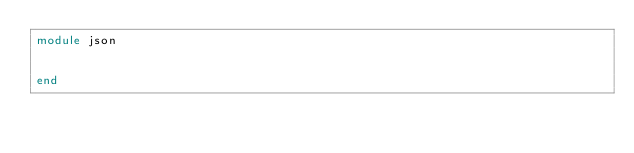Convert code to text. <code><loc_0><loc_0><loc_500><loc_500><_Julia_>module json


end
</code> 